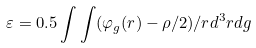Convert formula to latex. <formula><loc_0><loc_0><loc_500><loc_500>\varepsilon = 0 . 5 \int \int ( \varphi _ { g } ( r ) - \rho / 2 ) / r d ^ { 3 } r d g</formula> 